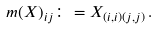<formula> <loc_0><loc_0><loc_500><loc_500>m ( X ) _ { i j } \colon = X _ { ( i , i ) ( j , j ) } \, .</formula> 